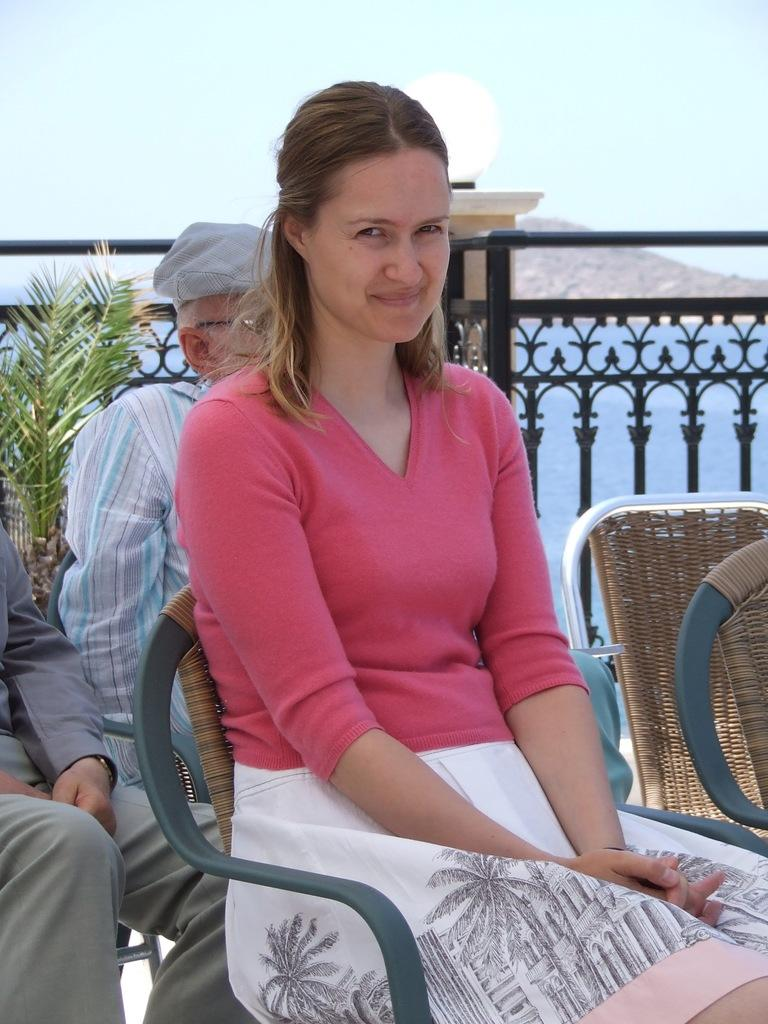How many people are sitting on the chair in the image? There are 3 people sitting on a chair in the image. Who is in the center of the group? A woman is in the center of the group. What expression does the woman have? The woman is smiling. What can be seen in the background of the image? There is a plant, a mountain, the sky, and water visible in the background. What type of tools does the carpenter have in the image? There is no carpenter present in the image. What show is the group watching in the image? There is no indication of a show being watched in the image. 